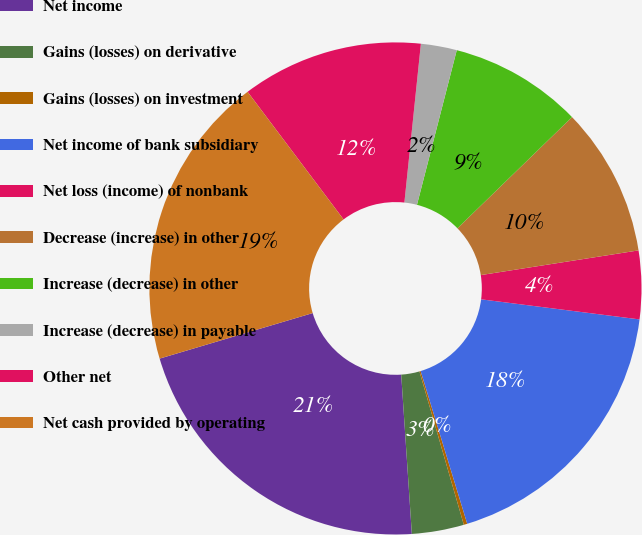Convert chart. <chart><loc_0><loc_0><loc_500><loc_500><pie_chart><fcel>Net income<fcel>Gains (losses) on derivative<fcel>Gains (losses) on investment<fcel>Net income of bank subsidiary<fcel>Net loss (income) of nonbank<fcel>Decrease (increase) in other<fcel>Increase (decrease) in other<fcel>Increase (decrease) in payable<fcel>Other net<fcel>Net cash provided by operating<nl><fcel>21.46%<fcel>3.42%<fcel>0.23%<fcel>18.28%<fcel>4.48%<fcel>9.79%<fcel>8.73%<fcel>2.36%<fcel>11.91%<fcel>19.34%<nl></chart> 